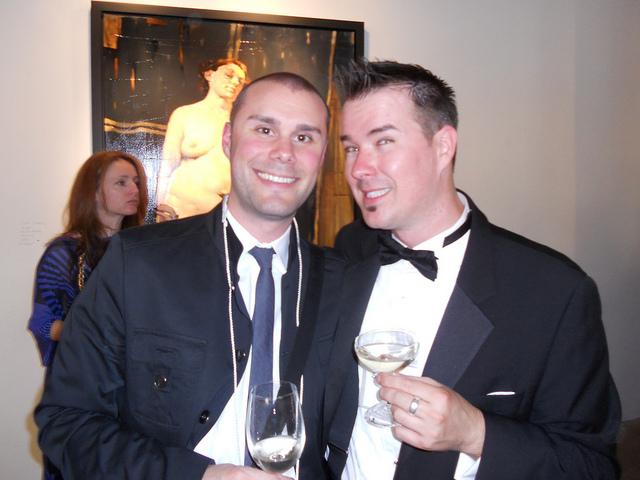From what fruit comes the item being drunk here? grapes 